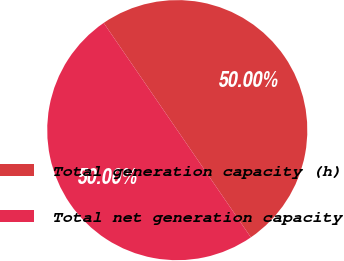Convert chart. <chart><loc_0><loc_0><loc_500><loc_500><pie_chart><fcel>Total generation capacity (h)<fcel>Total net generation capacity<nl><fcel>50.0%<fcel>50.0%<nl></chart> 